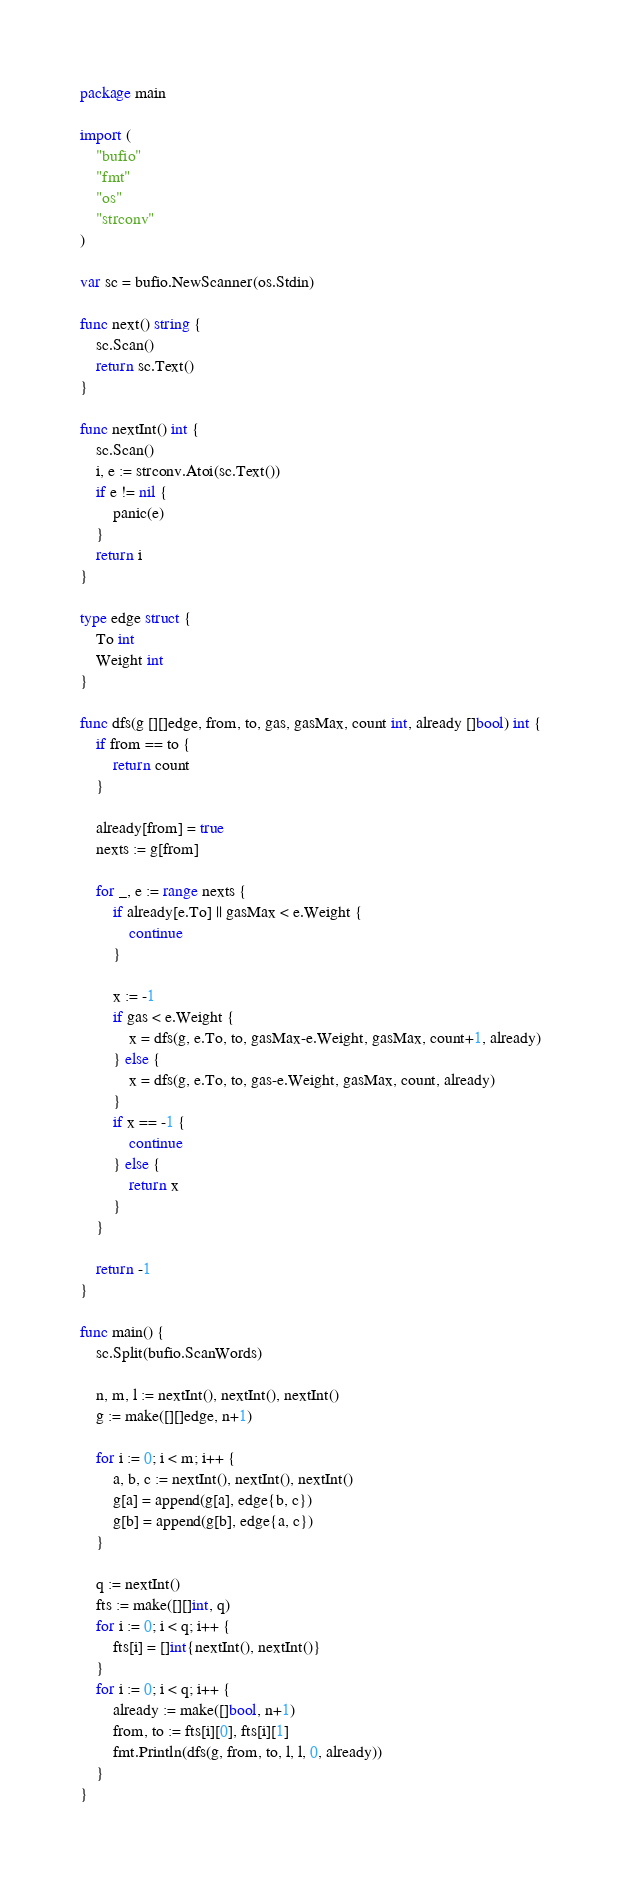Convert code to text. <code><loc_0><loc_0><loc_500><loc_500><_Go_>package main

import (
	"bufio"
	"fmt"
	"os"
	"strconv"
)

var sc = bufio.NewScanner(os.Stdin)

func next() string {
	sc.Scan()
	return sc.Text()
}

func nextInt() int {
	sc.Scan()
	i, e := strconv.Atoi(sc.Text())
	if e != nil {
		panic(e)
	}
	return i
}

type edge struct {
	To int
	Weight int
}

func dfs(g [][]edge, from, to, gas, gasMax, count int, already []bool) int {
	if from == to {
		return count
	}

	already[from] = true
	nexts := g[from]

	for _, e := range nexts {
		if already[e.To] || gasMax < e.Weight {
			continue
		}

		x := -1
		if gas < e.Weight {
			x = dfs(g, e.To, to, gasMax-e.Weight, gasMax, count+1, already)
		} else {
			x = dfs(g, e.To, to, gas-e.Weight, gasMax, count, already)
		}
		if x == -1 {
			continue
		} else {
			return x
		}
	}

	return -1
}

func main() {
	sc.Split(bufio.ScanWords)

	n, m, l := nextInt(), nextInt(), nextInt()
	g := make([][]edge, n+1)

	for i := 0; i < m; i++ {
		a, b, c := nextInt(), nextInt(), nextInt()
		g[a] = append(g[a], edge{b, c})
		g[b] = append(g[b], edge{a, c})
	}

	q := nextInt()
	fts := make([][]int, q)
	for i := 0; i < q; i++ {
		fts[i] = []int{nextInt(), nextInt()}
	}
	for i := 0; i < q; i++ {
		already := make([]bool, n+1)
		from, to := fts[i][0], fts[i][1]
		fmt.Println(dfs(g, from, to, l, l, 0, already))
	}
}</code> 